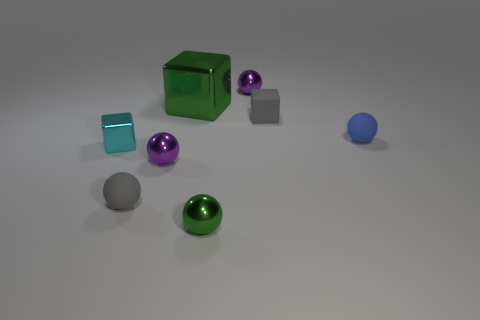How many yellow metallic balls have the same size as the matte block?
Provide a succinct answer. 0. What number of things are either small gray rubber things in front of the blue ball or brown metallic cylinders?
Offer a very short reply. 1. Is the number of cyan metallic cubes less than the number of large cyan things?
Give a very brief answer. No. What shape is the cyan thing that is made of the same material as the large green block?
Give a very brief answer. Cube. Are there any green metallic objects behind the cyan thing?
Keep it short and to the point. Yes. Is the number of small cubes in front of the small blue sphere less than the number of small purple objects?
Offer a very short reply. Yes. What is the material of the tiny blue sphere?
Give a very brief answer. Rubber. What color is the small metallic block?
Your response must be concise. Cyan. There is a tiny shiny thing that is both behind the green ball and on the right side of the large cube; what color is it?
Your response must be concise. Purple. Is the gray block made of the same material as the tiny gray thing that is in front of the tiny cyan metal cube?
Provide a short and direct response. Yes. 